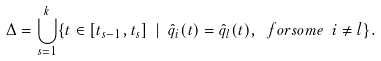<formula> <loc_0><loc_0><loc_500><loc_500>\Delta = \bigcup _ { s = 1 } ^ { k } \{ t \in [ t _ { s - 1 } , t _ { s } ] \ | \ \hat { q } _ { i } ( t ) = \hat { q } _ { l } ( t ) , \ f o r s o m e \ i \neq l \} .</formula> 